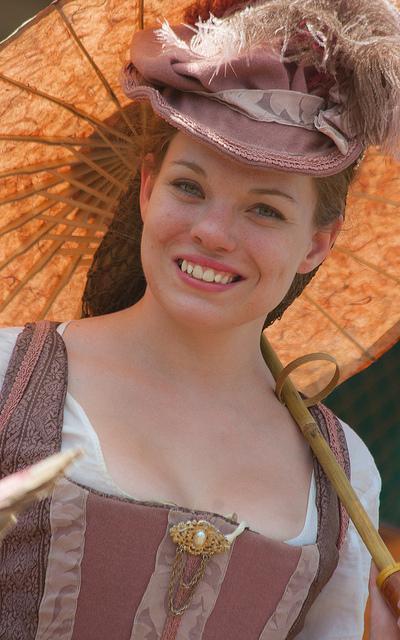How many people are shown?
Give a very brief answer. 1. 